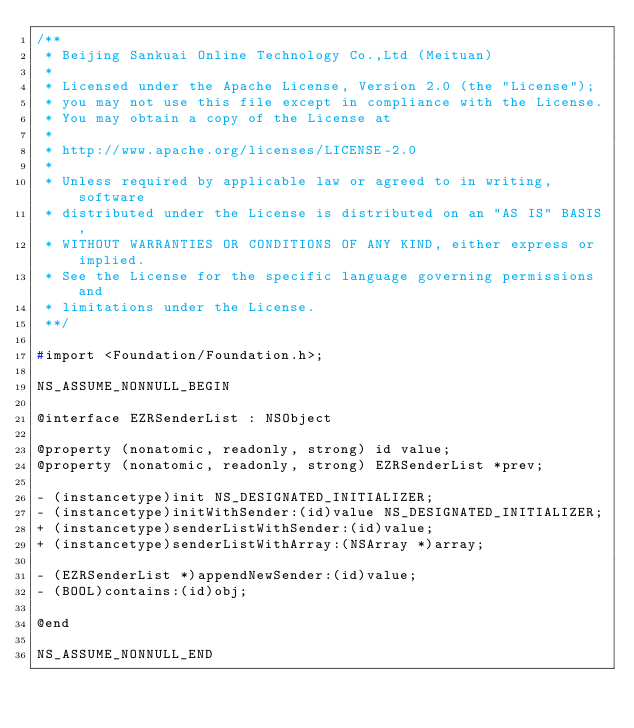<code> <loc_0><loc_0><loc_500><loc_500><_C_>/**
 * Beijing Sankuai Online Technology Co.,Ltd (Meituan)
 *
 * Licensed under the Apache License, Version 2.0 (the "License");
 * you may not use this file except in compliance with the License.
 * You may obtain a copy of the License at
 *
 * http://www.apache.org/licenses/LICENSE-2.0
 *
 * Unless required by applicable law or agreed to in writing, software
 * distributed under the License is distributed on an "AS IS" BASIS,
 * WITHOUT WARRANTIES OR CONDITIONS OF ANY KIND, either express or implied.
 * See the License for the specific language governing permissions and
 * limitations under the License.
 **/

#import <Foundation/Foundation.h>;

NS_ASSUME_NONNULL_BEGIN

@interface EZRSenderList : NSObject

@property (nonatomic, readonly, strong) id value;
@property (nonatomic, readonly, strong) EZRSenderList *prev;

- (instancetype)init NS_DESIGNATED_INITIALIZER;
- (instancetype)initWithSender:(id)value NS_DESIGNATED_INITIALIZER;
+ (instancetype)senderListWithSender:(id)value;
+ (instancetype)senderListWithArray:(NSArray *)array;

- (EZRSenderList *)appendNewSender:(id)value;
- (BOOL)contains:(id)obj;

@end

NS_ASSUME_NONNULL_END
</code> 